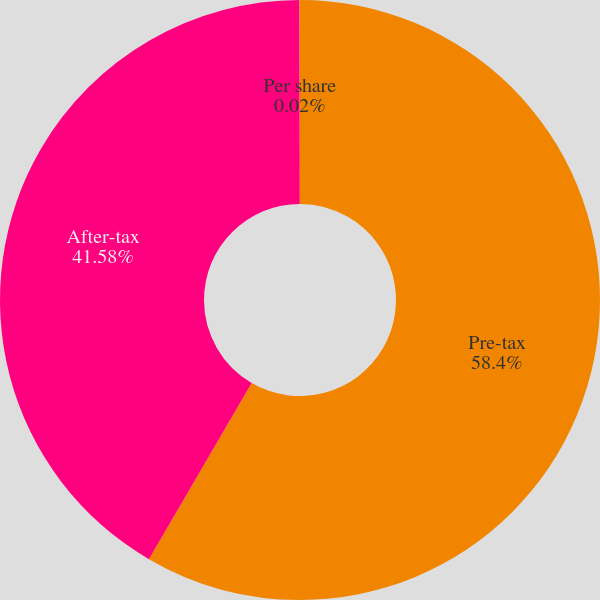Convert chart to OTSL. <chart><loc_0><loc_0><loc_500><loc_500><pie_chart><fcel>Pre-tax<fcel>After-tax<fcel>Per share<nl><fcel>58.4%<fcel>41.58%<fcel>0.02%<nl></chart> 